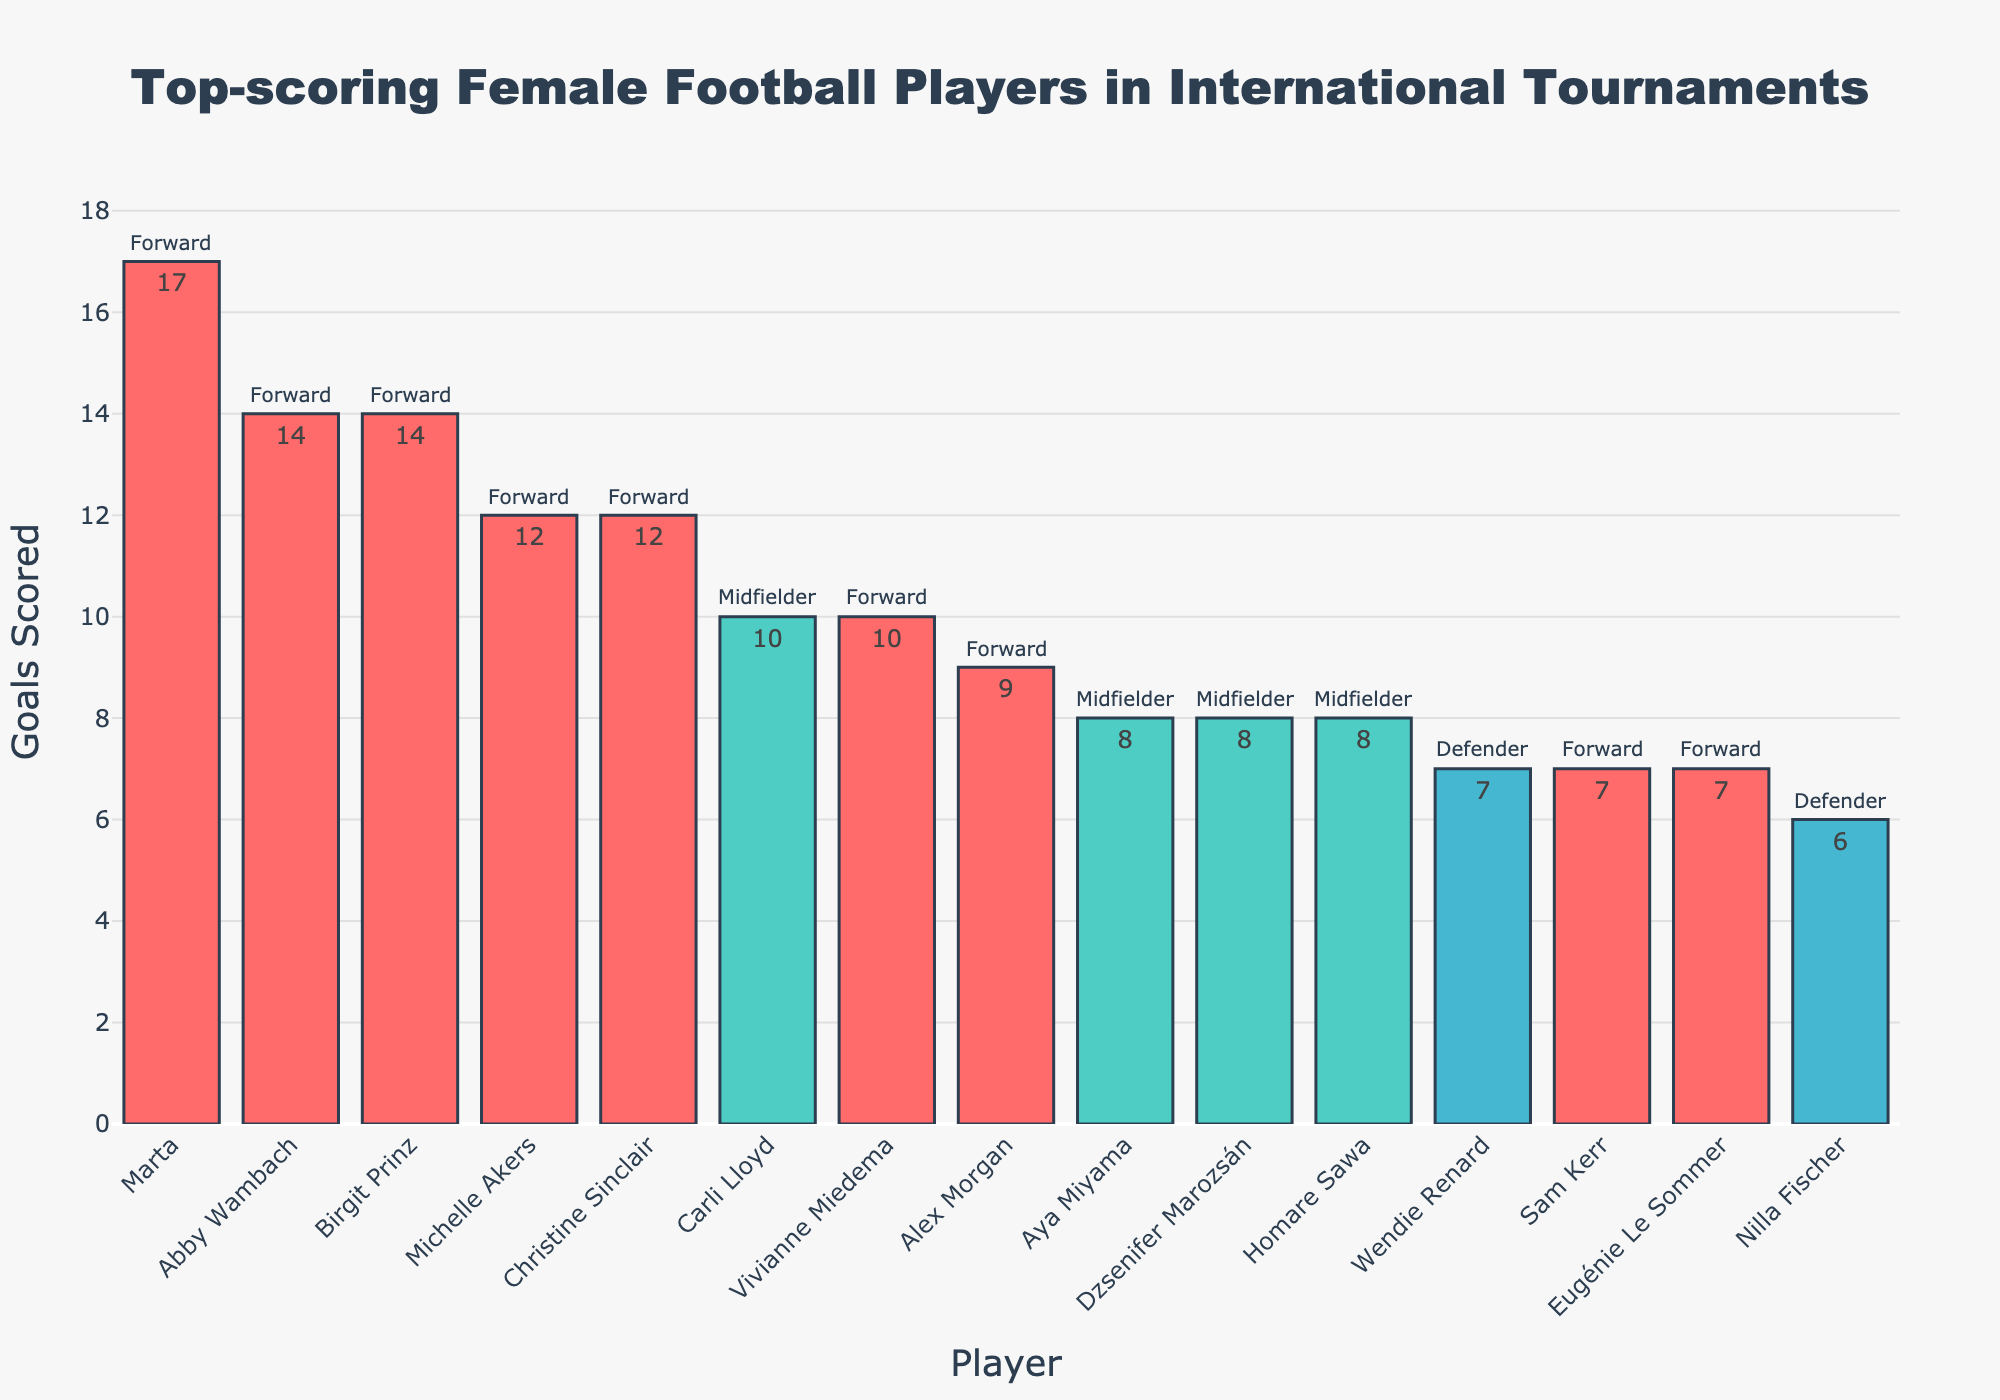What player has the highest number of goals? The tallest bar in the chart represents Marta, indicating she has the highest number of goals.
Answer: Marta How many goals were scored by Midfielders? Add the goals scored by Carli Lloyd (10), Aya Miyama (8), Dzsenifer Marozsán (8), and Homare Sawa (8). Therefore, the total is 10 + 8 + 8 + 8 = 34.
Answer: 34 Who scored more goals, Christine Sinclair or Michelle Akers? Compare the heights of the bars for Christine Sinclair and Michelle Akers. Both bars indicate that they scored 12 goals each.
Answer: Both scored 12 goals What is the total number of goals scored by players in the Olympic Games? Sum the goals scored by Christine Sinclair (12) and Alex Morgan (9). Therefore, 12 + 9 = 21.
Answer: 21 Which defender has scored the most goals? Compare the bars for Wendie Renard and Nilla Fischer (the only defenders). Wendie Renard's bar is taller, indicating she scored more goals.
Answer: Wendie Renard Who has scored more goals in FIFA Women's World Cup tournaments, Carli Lloyd or Abby Wambach? Compare the bars for Carli Lloyd and Abby Wambach. Abby Wambach's bar, with 14 goals, is taller than Carli Lloyd's with 10 goals.
Answer: Abby Wambach What is the difference in goals scored between the top Forward and the top Midfielder? The top Forward is Marta with 17 goals, and the top Midfielder is Carli Lloyd with 10 goals. Subtract 10 from 17, resulting in 7.
Answer: 7 How many players have scored more than 10 goals? Count the bars representing players with more than 10 goals: Marta (17), Abby Wambach (14), Birgit Prinz (14), Michelle Akers (12), Christine Sinclair (12). There are 5 players in total.
Answer: 5 How many goals have the top 3 scorers collectively scored? Sum the goals of Marta (17), Abby Wambach (14), and Birgit Prinz (14). Therefore, 17 + 14 + 14 = 45.
Answer: 45 What is the average number of goals scored by the top 4 Forwards? Sum the goals of Marta (17), Abby Wambach (14), Birgit Prinz (14), and Michelle Akers (12). Then divide by 4. Therefore, (17 + 14 + 14 + 12) / 4 = 57 / 4 = 14.25.
Answer: 14.25 